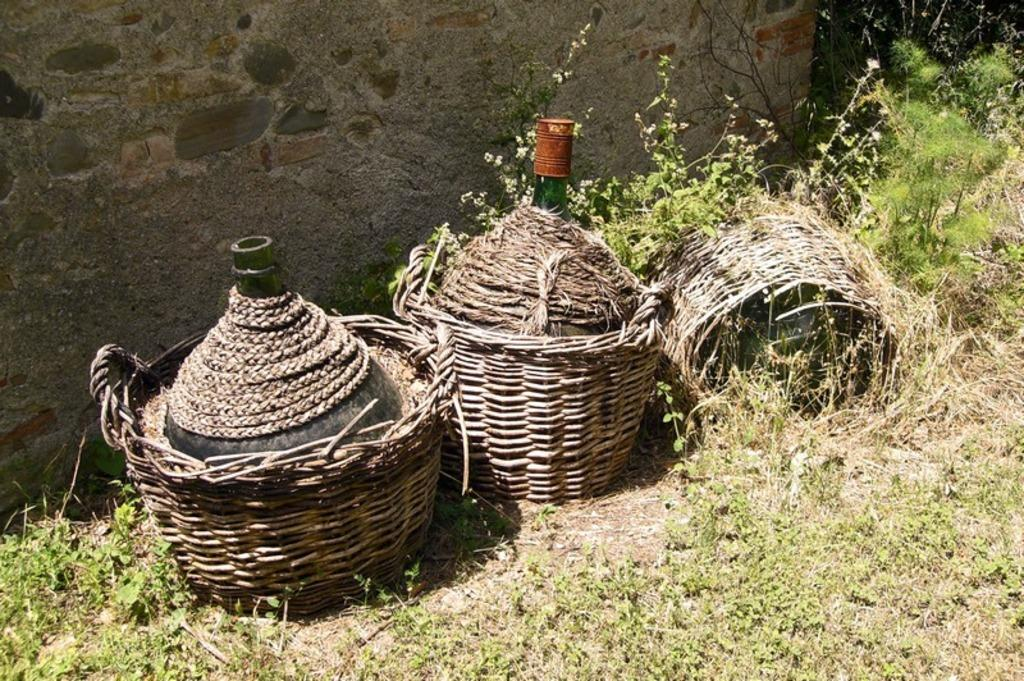What can be seen in the background of the image? There is a wall in the background of the image. What objects are present in the image? There are buckets and other objects visible in the image. What type of clothing can be seen in the image? Pants are visible in the image. What is the surface on which the objects are placed or standing? The ground is visible in the image. Where is the throne located in the image? There is no throne present in the image. How many planes can be seen flying in the image? There are no planes visible in the image. 